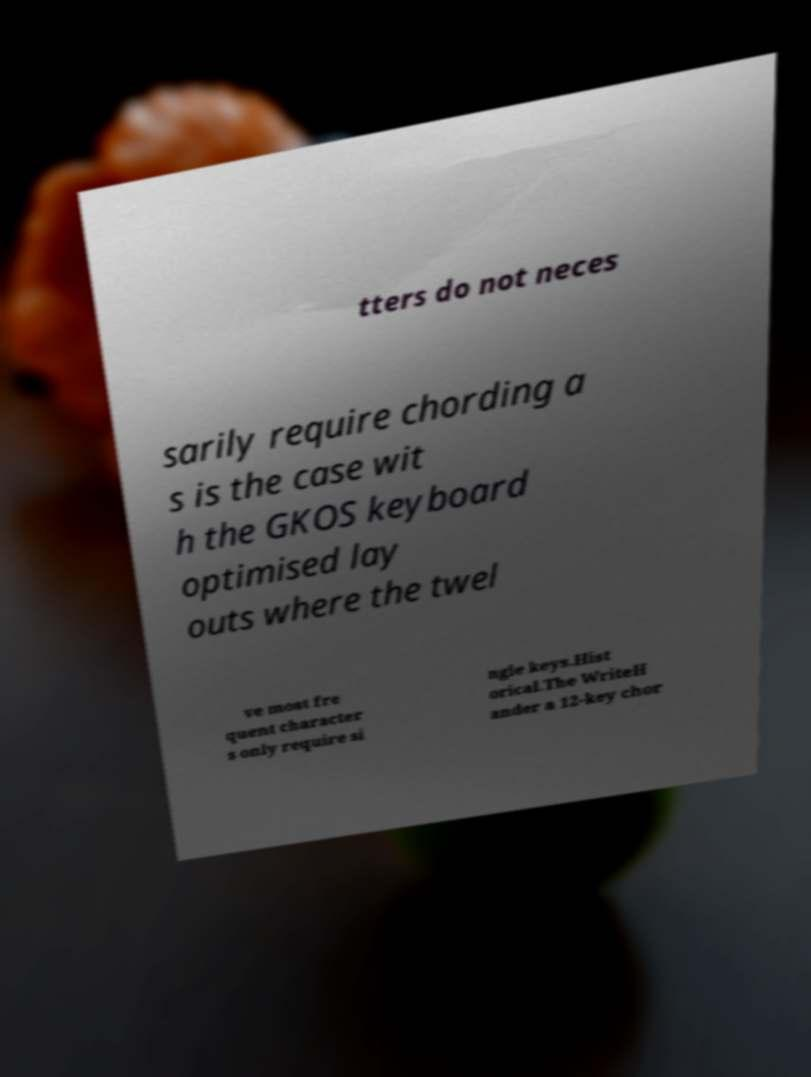Could you extract and type out the text from this image? tters do not neces sarily require chording a s is the case wit h the GKOS keyboard optimised lay outs where the twel ve most fre quent character s only require si ngle keys.Hist orical.The WriteH ander a 12-key chor 